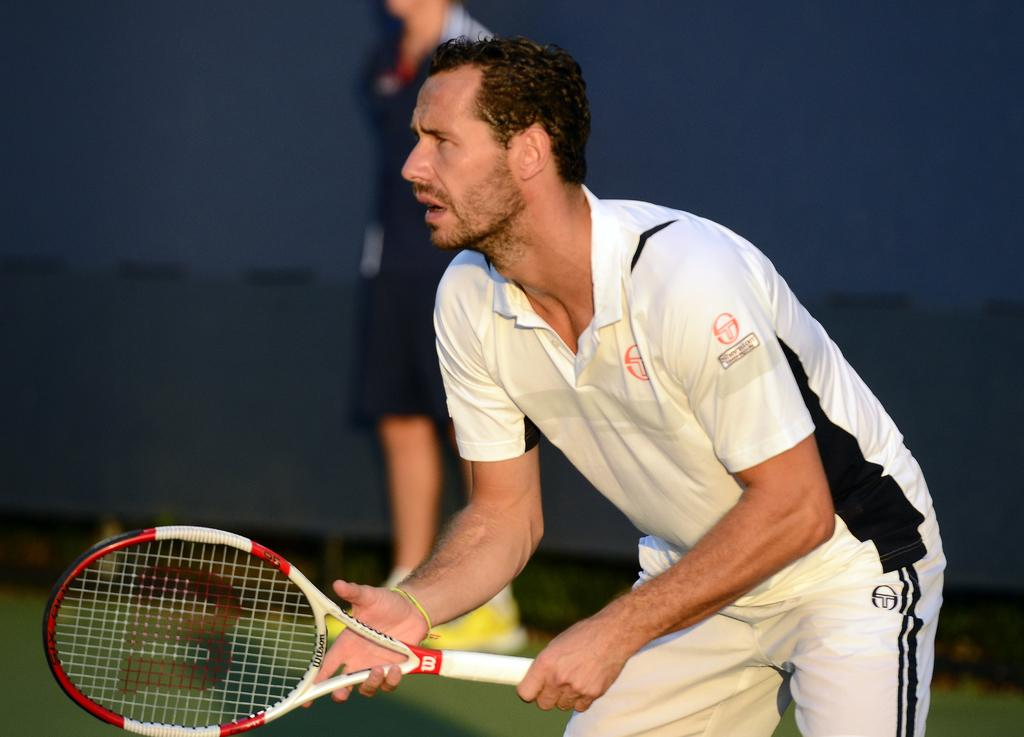Who or what is the main subject of the image? There is a person in the image. What is the person wearing? The person is wearing a white dress. What object is the person holding? The person is holding a tennis racket. Can you describe the background of the image? The background of the image is blurred. What type of news can be seen on the person's shirt in the image? There is no news or text visible on the person's shirt in the image. How is the glue being used by the person in the image? There is no glue present in the image, and therefore no such activity can be observed. 